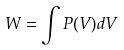Convert formula to latex. <formula><loc_0><loc_0><loc_500><loc_500>W = \int P ( V ) d V</formula> 